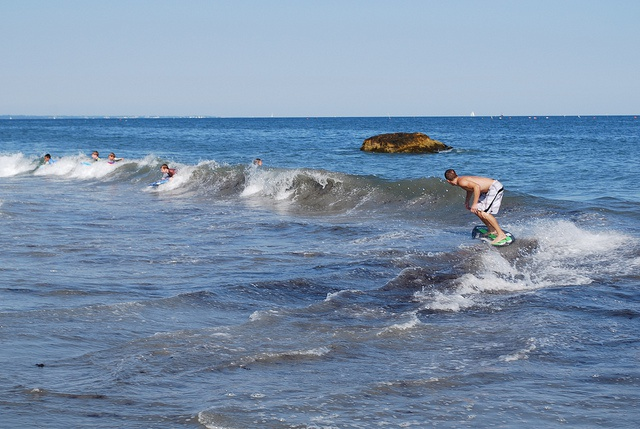Describe the objects in this image and their specific colors. I can see people in lightblue, lavender, tan, gray, and maroon tones, surfboard in lightblue, gray, teal, lightgray, and green tones, people in lightblue, darkgray, brown, lightpink, and gray tones, surfboard in lightblue, lightgray, and darkgray tones, and people in lightblue, gray, and darkgray tones in this image. 